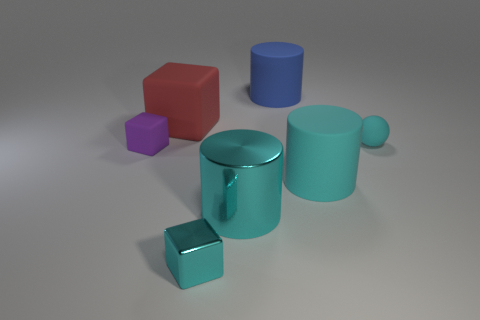Subtract all rubber blocks. How many blocks are left? 1 Subtract all red cubes. How many cubes are left? 2 Subtract 2 cubes. How many cubes are left? 1 Add 1 large red objects. How many objects exist? 8 Subtract all spheres. How many objects are left? 6 Subtract all blue cubes. How many cyan cylinders are left? 2 Subtract all small blocks. Subtract all big red metal cubes. How many objects are left? 5 Add 7 cylinders. How many cylinders are left? 10 Add 1 big blue cubes. How many big blue cubes exist? 1 Subtract 0 purple cylinders. How many objects are left? 7 